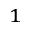Convert formula to latex. <formula><loc_0><loc_0><loc_500><loc_500>^ { 1 }</formula> 